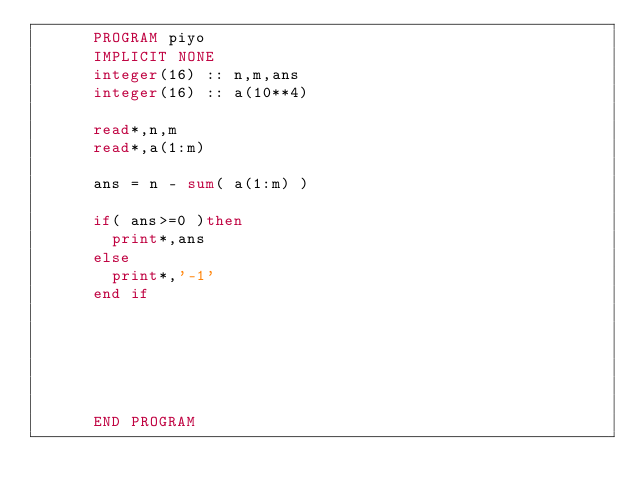Convert code to text. <code><loc_0><loc_0><loc_500><loc_500><_FORTRAN_>      PROGRAM piyo
      IMPLICIT NONE
      integer(16) :: n,m,ans
      integer(16) :: a(10**4)
      
      read*,n,m
      read*,a(1:m)
      
      ans = n - sum( a(1:m) )
      
      if( ans>=0 )then
        print*,ans
      else
        print*,'-1'
      end if
      
      
      
      
      
      
      END PROGRAM</code> 